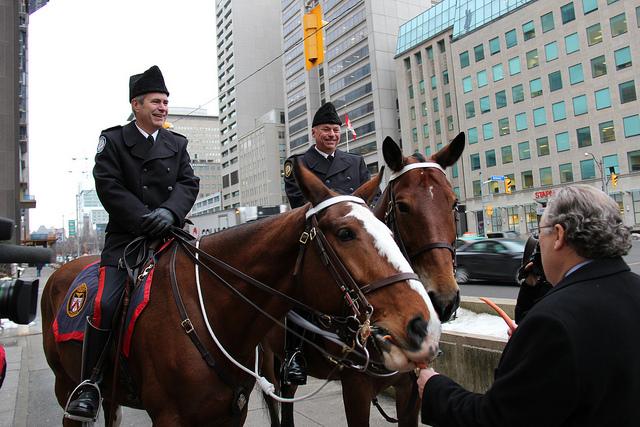How many pairs of glasses?
Be succinct. 1. Do you see any tall buildings?
Keep it brief. Yes. How many horses?
Write a very short answer. 2. What would you call the men in this photo?
Quick response, please. Soldiers. What color is the car?
Be succinct. Black. What color is the cloth under the saddle of the horse in the foreground?
Concise answer only. Blue. What is in the horses mouth?
Quick response, please. Food. 